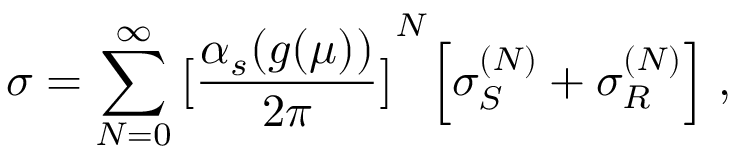<formula> <loc_0><loc_0><loc_500><loc_500>\sigma = \sum _ { N = 0 } ^ { \infty } { \left [ { \frac { \alpha _ { s } ( g ( \mu ) ) } { 2 \pi } } \right ] } ^ { N } \left [ \sigma _ { S } ^ { ( N ) } + \sigma _ { R } ^ { ( N ) } \right ] \, ,</formula> 